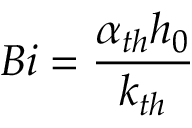Convert formula to latex. <formula><loc_0><loc_0><loc_500><loc_500>B i = \frac { \alpha _ { t h } h _ { 0 } } { k _ { t h } }</formula> 